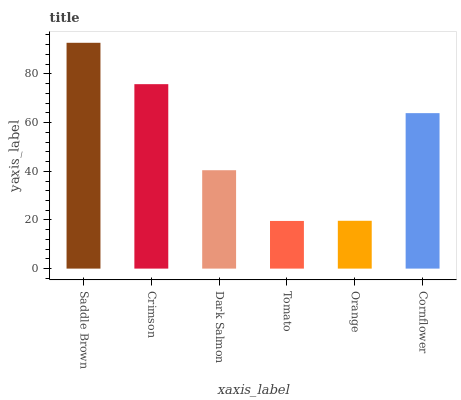Is Tomato the minimum?
Answer yes or no. Yes. Is Saddle Brown the maximum?
Answer yes or no. Yes. Is Crimson the minimum?
Answer yes or no. No. Is Crimson the maximum?
Answer yes or no. No. Is Saddle Brown greater than Crimson?
Answer yes or no. Yes. Is Crimson less than Saddle Brown?
Answer yes or no. Yes. Is Crimson greater than Saddle Brown?
Answer yes or no. No. Is Saddle Brown less than Crimson?
Answer yes or no. No. Is Cornflower the high median?
Answer yes or no. Yes. Is Dark Salmon the low median?
Answer yes or no. Yes. Is Tomato the high median?
Answer yes or no. No. Is Orange the low median?
Answer yes or no. No. 